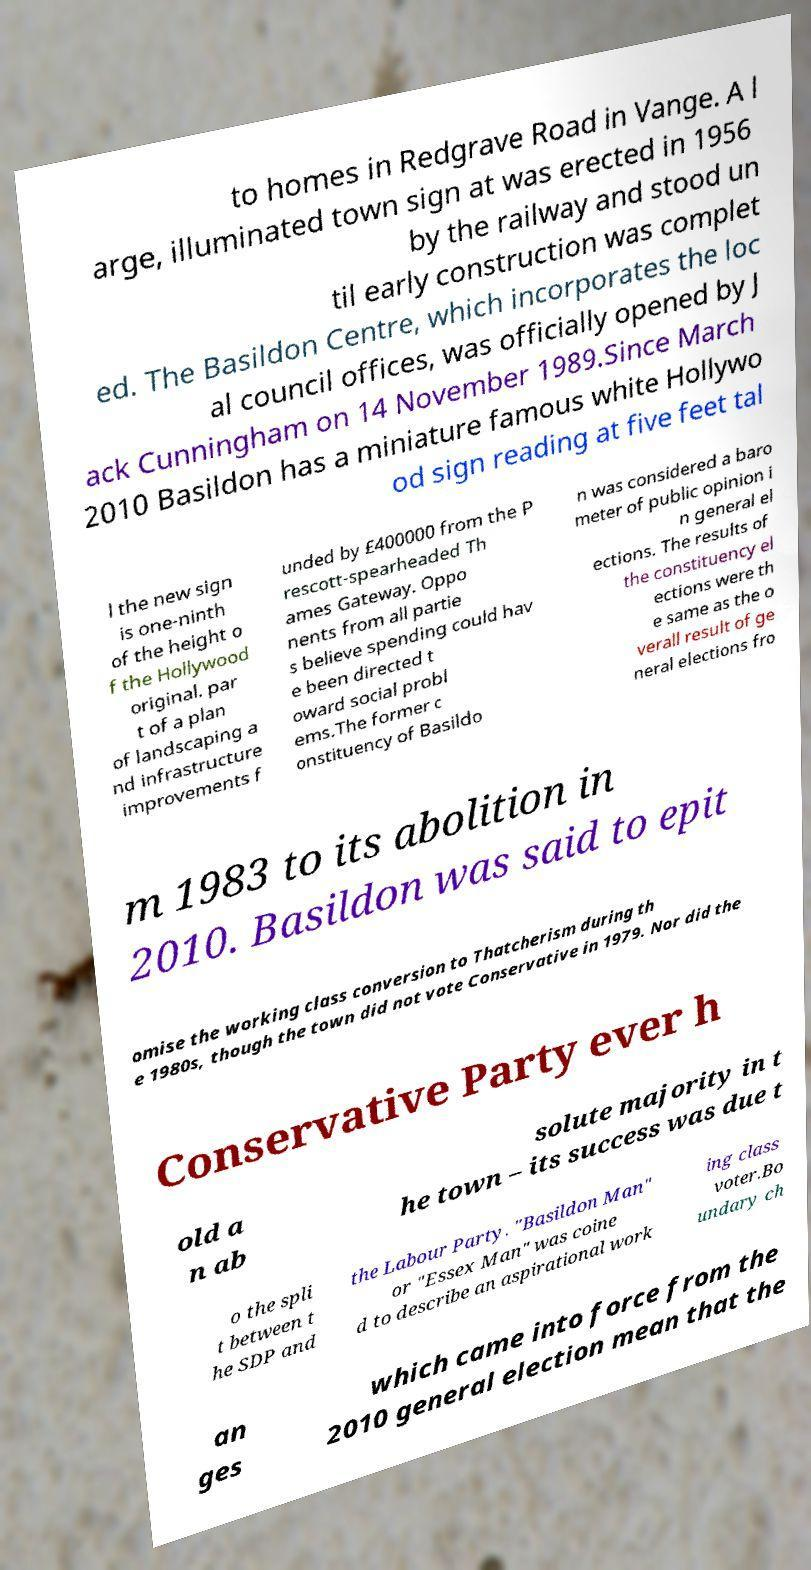Could you extract and type out the text from this image? to homes in Redgrave Road in Vange. A l arge, illuminated town sign at was erected in 1956 by the railway and stood un til early construction was complet ed. The Basildon Centre, which incorporates the loc al council offices, was officially opened by J ack Cunningham on 14 November 1989.Since March 2010 Basildon has a miniature famous white Hollywo od sign reading at five feet tal l the new sign is one-ninth of the height o f the Hollywood original. par t of a plan of landscaping a nd infrastructure improvements f unded by £400000 from the P rescott-spearheaded Th ames Gateway. Oppo nents from all partie s believe spending could hav e been directed t oward social probl ems.The former c onstituency of Basildo n was considered a baro meter of public opinion i n general el ections. The results of the constituency el ections were th e same as the o verall result of ge neral elections fro m 1983 to its abolition in 2010. Basildon was said to epit omise the working class conversion to Thatcherism during th e 1980s, though the town did not vote Conservative in 1979. Nor did the Conservative Party ever h old a n ab solute majority in t he town – its success was due t o the spli t between t he SDP and the Labour Party. "Basildon Man" or "Essex Man" was coine d to describe an aspirational work ing class voter.Bo undary ch an ges which came into force from the 2010 general election mean that the 